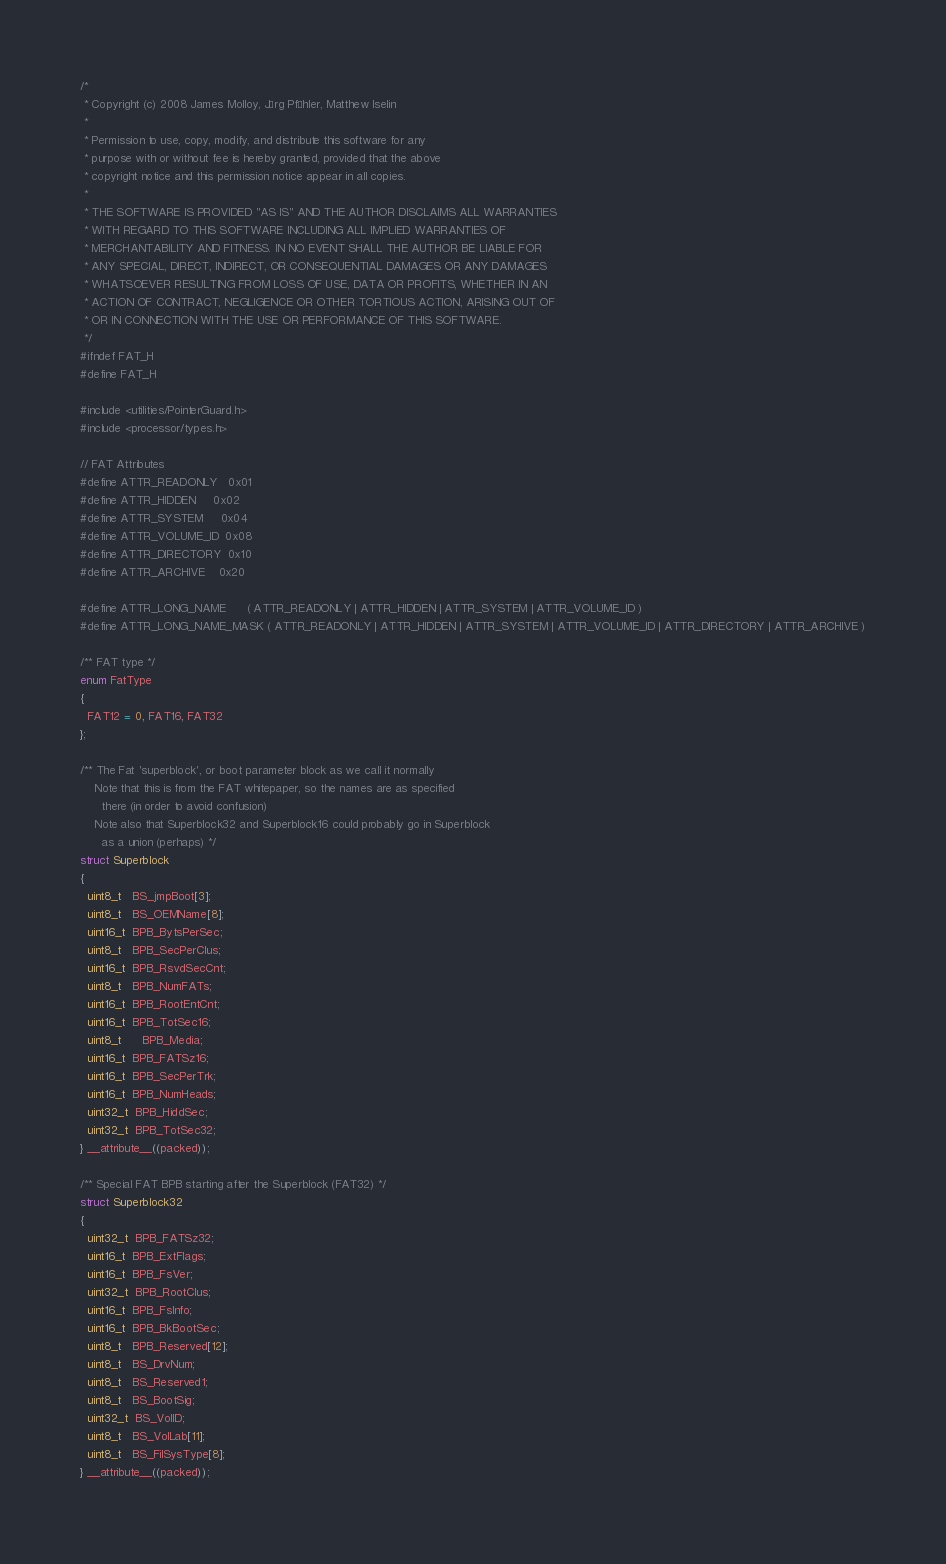Convert code to text. <code><loc_0><loc_0><loc_500><loc_500><_C_>/*
 * Copyright (c) 2008 James Molloy, Jörg Pfähler, Matthew Iselin
 *
 * Permission to use, copy, modify, and distribute this software for any
 * purpose with or without fee is hereby granted, provided that the above
 * copyright notice and this permission notice appear in all copies.
 *
 * THE SOFTWARE IS PROVIDED "AS IS" AND THE AUTHOR DISCLAIMS ALL WARRANTIES
 * WITH REGARD TO THIS SOFTWARE INCLUDING ALL IMPLIED WARRANTIES OF
 * MERCHANTABILITY AND FITNESS. IN NO EVENT SHALL THE AUTHOR BE LIABLE FOR
 * ANY SPECIAL, DIRECT, INDIRECT, OR CONSEQUENTIAL DAMAGES OR ANY DAMAGES
 * WHATSOEVER RESULTING FROM LOSS OF USE, DATA OR PROFITS, WHETHER IN AN
 * ACTION OF CONTRACT, NEGLIGENCE OR OTHER TORTIOUS ACTION, ARISING OUT OF
 * OR IN CONNECTION WITH THE USE OR PERFORMANCE OF THIS SOFTWARE.
 */
#ifndef FAT_H
#define FAT_H

#include <utilities/PointerGuard.h>
#include <processor/types.h>

// FAT Attributes
#define ATTR_READONLY   0x01
#define ATTR_HIDDEN     0x02
#define ATTR_SYSTEM     0x04
#define ATTR_VOLUME_ID  0x08
#define ATTR_DIRECTORY  0x10
#define ATTR_ARCHIVE    0x20

#define ATTR_LONG_NAME      ( ATTR_READONLY | ATTR_HIDDEN | ATTR_SYSTEM | ATTR_VOLUME_ID )
#define ATTR_LONG_NAME_MASK ( ATTR_READONLY | ATTR_HIDDEN | ATTR_SYSTEM | ATTR_VOLUME_ID | ATTR_DIRECTORY | ATTR_ARCHIVE )

/** FAT type */
enum FatType
{
  FAT12 = 0, FAT16, FAT32
};

/** The Fat 'superblock', or boot parameter block as we call it normally
    Note that this is from the FAT whitepaper, so the names are as specified
      there (in order to avoid confusion)
    Note also that Superblock32 and Superblock16 could probably go in Superblock
      as a union (perhaps) */
struct Superblock
{
  uint8_t   BS_jmpBoot[3];
  uint8_t   BS_OEMName[8];
  uint16_t  BPB_BytsPerSec;
  uint8_t   BPB_SecPerClus;
  uint16_t  BPB_RsvdSecCnt;
  uint8_t   BPB_NumFATs;
  uint16_t  BPB_RootEntCnt;
  uint16_t  BPB_TotSec16;
  uint8_t	  BPB_Media;
  uint16_t  BPB_FATSz16;
  uint16_t  BPB_SecPerTrk;
  uint16_t  BPB_NumHeads;
  uint32_t  BPB_HiddSec;
  uint32_t  BPB_TotSec32;
} __attribute__((packed));

/** Special FAT BPB starting after the Superblock (FAT32) */
struct Superblock32
{
  uint32_t  BPB_FATSz32;
  uint16_t  BPB_ExtFlags;
  uint16_t  BPB_FsVer;
  uint32_t  BPB_RootClus;
  uint16_t  BPB_FsInfo;
  uint16_t  BPB_BkBootSec;
  uint8_t   BPB_Reserved[12];
  uint8_t   BS_DrvNum;
  uint8_t   BS_Reserved1;
  uint8_t   BS_BootSig;
  uint32_t  BS_VolID;
  uint8_t   BS_VolLab[11];
  uint8_t   BS_FilSysType[8];
} __attribute__((packed));
</code> 